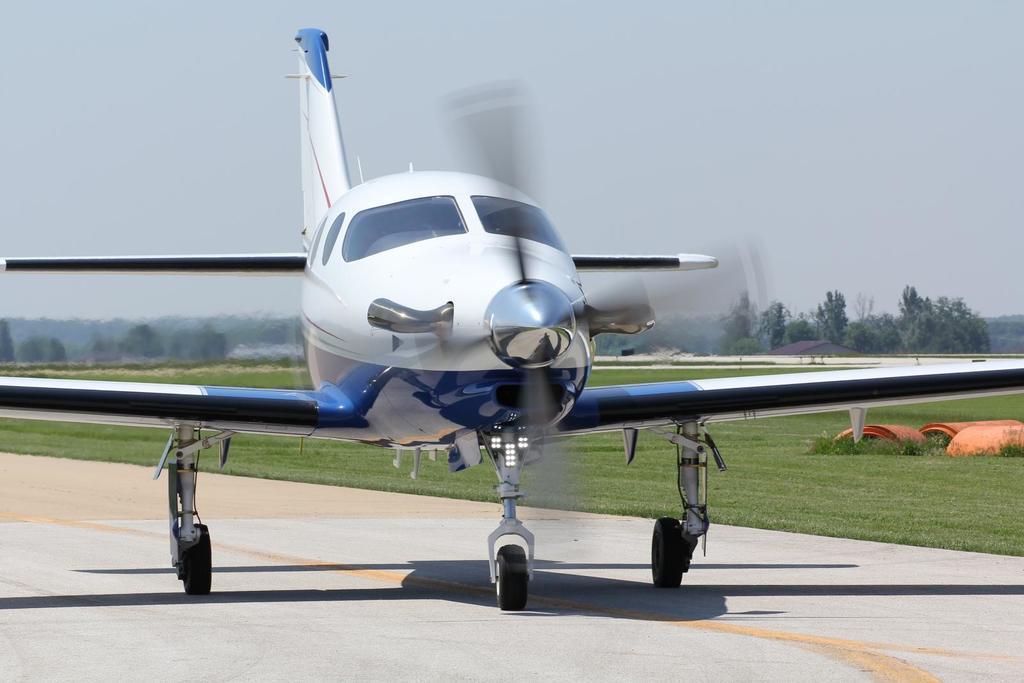In one or two sentences, can you explain what this image depicts? Here we can see an aeroplane on the road. In the background there are objects on the right side on the grass and we can see trees and sky. 